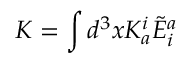<formula> <loc_0><loc_0><loc_500><loc_500>K = \int d ^ { 3 } x K _ { a } ^ { i } { \tilde { E } } _ { i } ^ { a }</formula> 